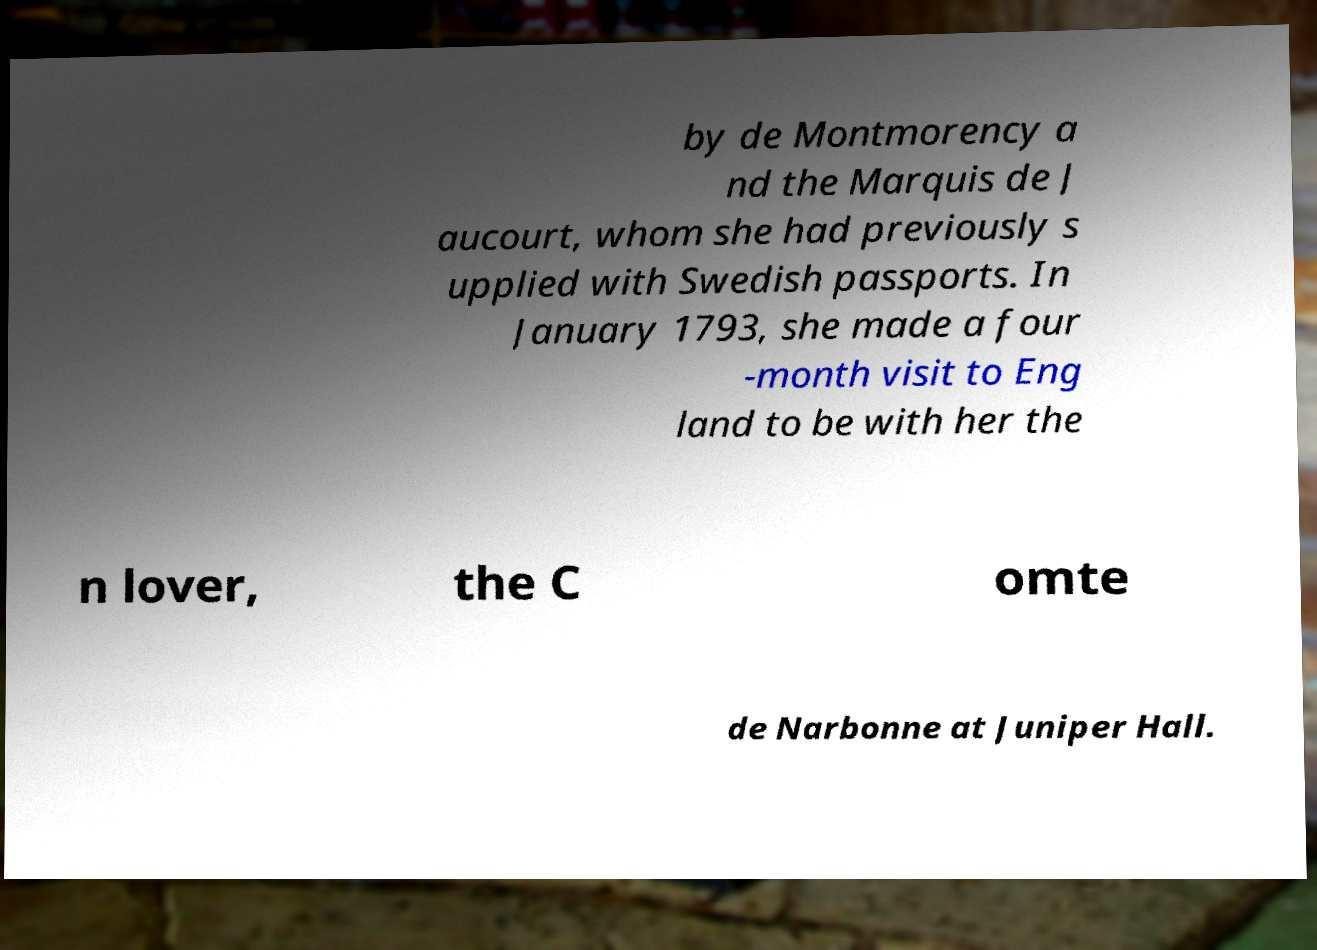Can you read and provide the text displayed in the image?This photo seems to have some interesting text. Can you extract and type it out for me? by de Montmorency a nd the Marquis de J aucourt, whom she had previously s upplied with Swedish passports. In January 1793, she made a four -month visit to Eng land to be with her the n lover, the C omte de Narbonne at Juniper Hall. 